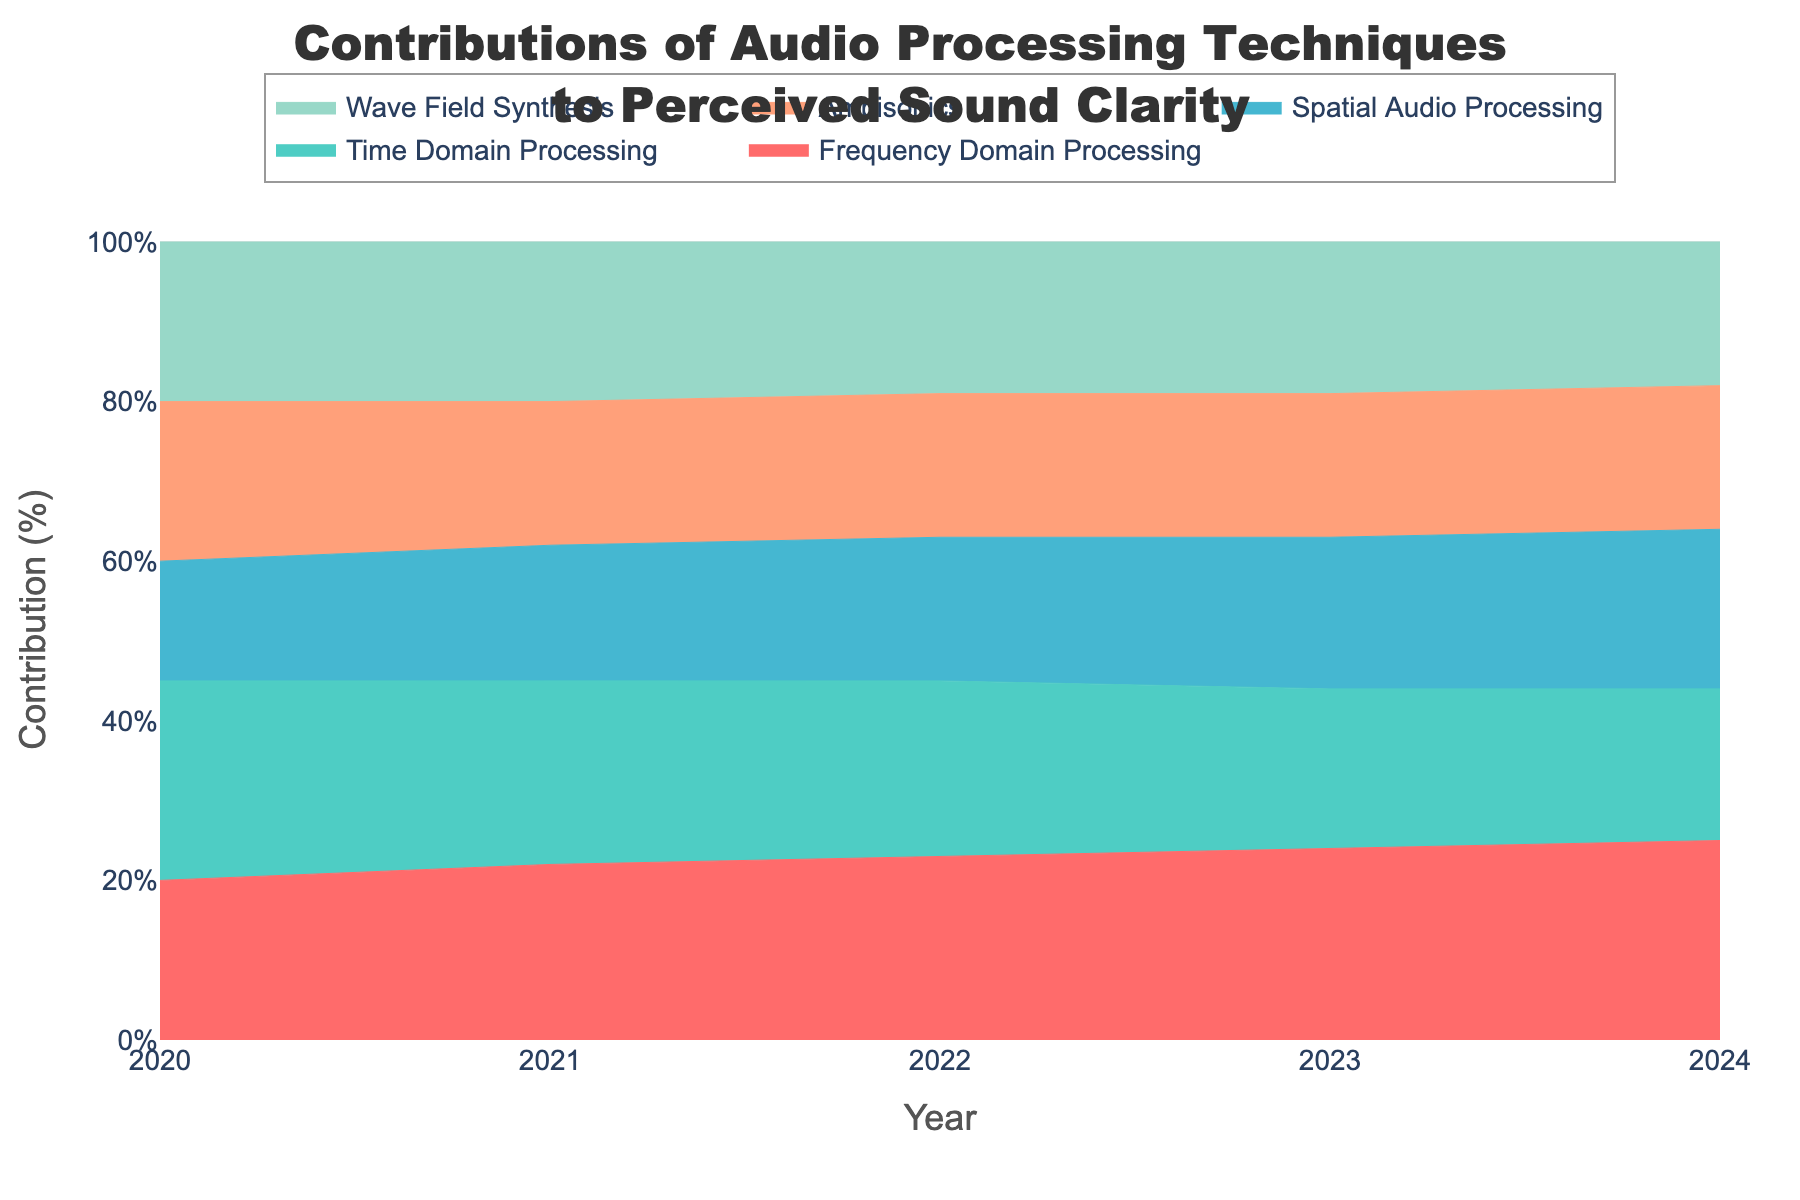What is the title of the figure? The title of the figure is usually displayed prominently at the top. Here, it reads "Contributions of Audio Processing Techniques to Perceived Sound Clarity".
Answer: Contributions of Audio Processing Techniques to Perceived Sound Clarity How many years of data are displayed in the figure? The x-axis of the figure represents the years, ranging from 2020 to 2024. Counting each year, we have five years of data shown in the figure.
Answer: 5 Which audio processing technique had the highest contribution in 2024? To answer this, we look at the highest section of the 100% stacked area chart for the year 2024. The top segment, by color, corresponds to "Frequency Domain Processing".
Answer: Frequency Domain Processing Between which years did "Time Domain Processing" decrease its contribution? The color corresponding to "Time Domain Processing" shows a declining trend. By examining the y-axis segments for each year, we note that it decreased from 2022 to 2024.
Answer: 2022 and 2024 Which technique had a consistent percentage contribution throughout the years? By scanning the area chart for segments that maintain a similar vertical width over the years, "Ambisonics" percentages appear consistent from 2020 to 2024.
Answer: Ambisonics What was the total contribution percentage of "Wave Field Synthesis" and "Ambisonics" in 2023? Checking 2023, "Wave Field Synthesis" has approximately 19% and "Ambisonics" also approximately 18%. Adding these two gives us their total contribution percentage for that year.
Answer: 37% Which technique has the smallest increase in contribution from 2020 to 2024? Observing the changes in areas over time, "Ambisonics" appears almost unchanged, indicating the smallest net increase among the techniques.
Answer: Ambisonics What is the trend of "Frequency Domain Processing" from 2020 to 2024? "Frequency Domain Processing" consistently increases each year, seen through its increasing vertical space in the stacked area chart.
Answer: Increasing Which two techniques' contributions combined make up almost 50% in 2022? In 2022, "Frequency Domain Processing" and "Time Domain Processing" together seem to cover nearly half the y-axis range when their contributions are summed.
Answer: Frequency Domain Processing and Time Domain Processing 